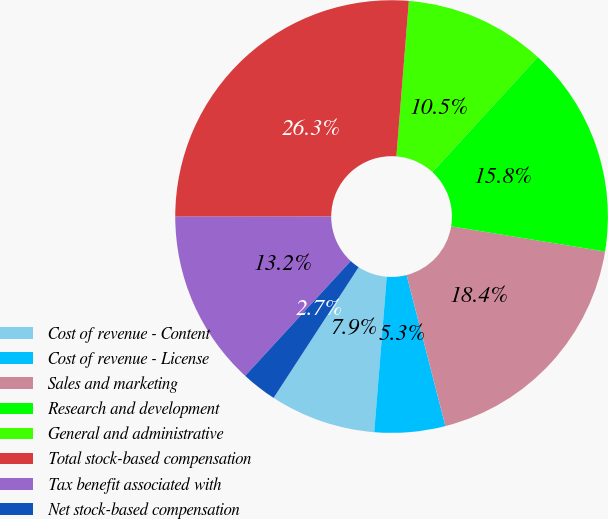Convert chart to OTSL. <chart><loc_0><loc_0><loc_500><loc_500><pie_chart><fcel>Cost of revenue - Content<fcel>Cost of revenue - License<fcel>Sales and marketing<fcel>Research and development<fcel>General and administrative<fcel>Total stock-based compensation<fcel>Tax benefit associated with<fcel>Net stock-based compensation<nl><fcel>7.9%<fcel>5.28%<fcel>18.41%<fcel>15.78%<fcel>10.53%<fcel>26.28%<fcel>13.16%<fcel>2.65%<nl></chart> 